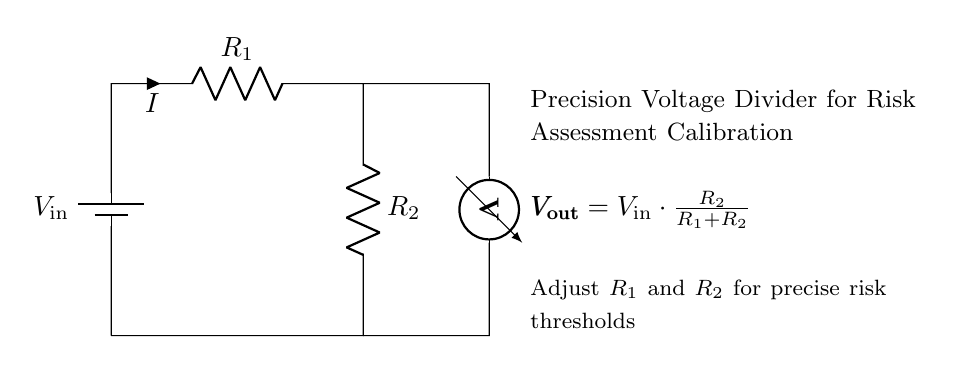What are the resistor values in the circuit? The schematic does not specify numerical values for the resistors R1 and R2, only that they are adjustable for calibration purposes.
Answer: Not specified What is the role of the battery in the circuit? The battery serves as the input voltage source, providing the necessary voltage for the voltage divider to function.
Answer: Input voltage source What is the formula for the output voltage in this circuit? The output voltage Vout is calculated using the formula Vout = Vin * (R2 / (R1 + R2)), which shows how the input voltage is divided between R1 and R2.
Answer: Vout = Vin * (R2 / (R1 + R2)) How can R1 and R2 be adjusted? The setup indicates that both resistors R1 and R2 can be varied to achieve the desired output voltage, allowing for precise calibration.
Answer: Adjusted for calibration What is the significance of the voltmeter in this circuit? The voltmeter measures the output voltage Vout across R2, providing essential data for monitoring the performance of the voltage divider.
Answer: Measures output voltage If R2 is very small compared to R1, what happens to Vout? If R2 is significantly smaller than R1, Vout approaches zero since less voltage would be available across R2 according to the voltage division equation.
Answer: Vout approaches zero 